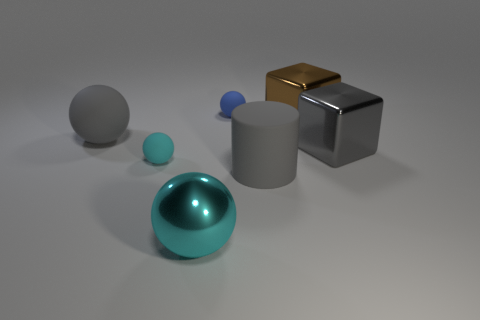What materials do the objects appear to be made of in this scene? The objects in the scene exhibit different materials. The large sphere in the foreground appears to be reflective, suggesting a polished metal or chrome coating. The smaller blue sphere looks like rubber due to its matte texture. The cylinder and one of the cubes have a dull, solid color, consistent with plastic or painted wood, while the brown cube presents a shiny, possibly metallic surface. 